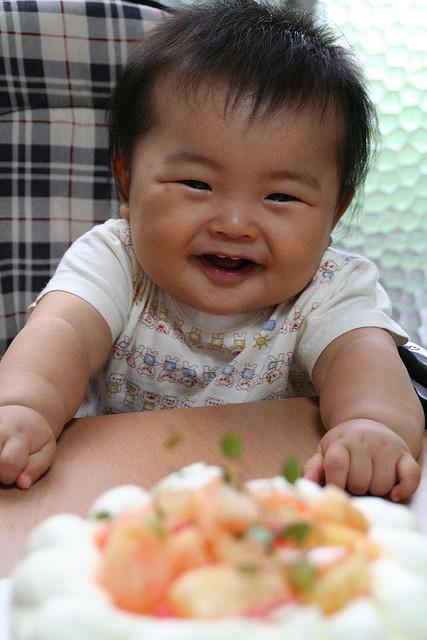What color is the baby's hair?
Be succinct. Black. Is this baby happy?
Answer briefly. Yes. Can this baby name all of the colors of her shirt?
Short answer required. No. Who is holding the baby?
Quick response, please. Nobody. 